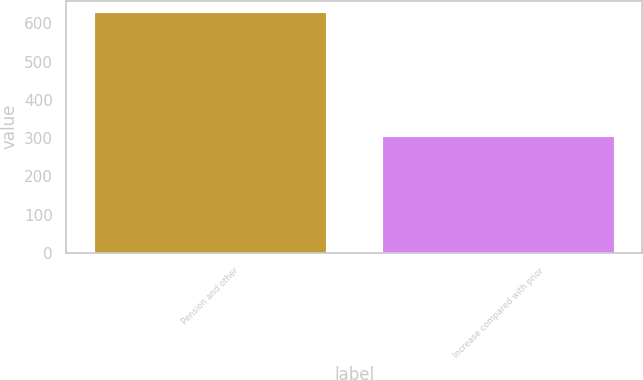<chart> <loc_0><loc_0><loc_500><loc_500><bar_chart><fcel>Pension and other<fcel>Increase compared with prior<nl><fcel>628<fcel>303<nl></chart> 